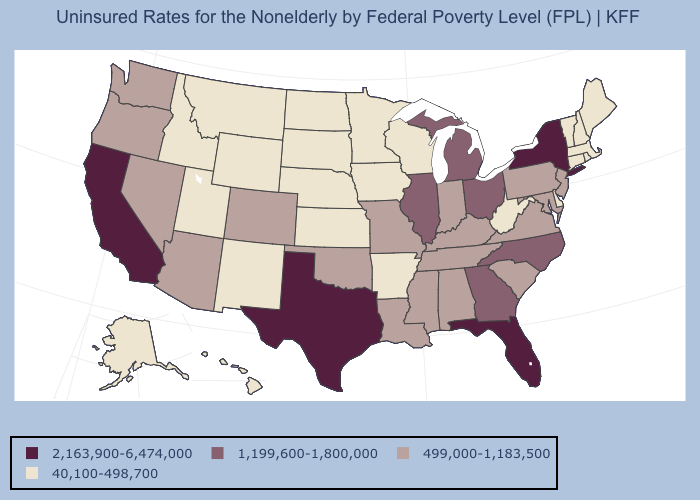Does Washington have a higher value than Illinois?
Give a very brief answer. No. What is the value of Delaware?
Answer briefly. 40,100-498,700. Among the states that border South Carolina , which have the highest value?
Short answer required. Georgia, North Carolina. Does the first symbol in the legend represent the smallest category?
Short answer required. No. Which states hav the highest value in the West?
Answer briefly. California. What is the highest value in the USA?
Concise answer only. 2,163,900-6,474,000. Name the states that have a value in the range 40,100-498,700?
Answer briefly. Alaska, Arkansas, Connecticut, Delaware, Hawaii, Idaho, Iowa, Kansas, Maine, Massachusetts, Minnesota, Montana, Nebraska, New Hampshire, New Mexico, North Dakota, Rhode Island, South Dakota, Utah, Vermont, West Virginia, Wisconsin, Wyoming. Does Florida have the highest value in the USA?
Be succinct. Yes. Among the states that border West Virginia , which have the lowest value?
Answer briefly. Kentucky, Maryland, Pennsylvania, Virginia. Which states hav the highest value in the MidWest?
Write a very short answer. Illinois, Michigan, Ohio. Name the states that have a value in the range 2,163,900-6,474,000?
Quick response, please. California, Florida, New York, Texas. Does Iowa have the lowest value in the USA?
Answer briefly. Yes. Does Ohio have the same value as Illinois?
Keep it brief. Yes. What is the value of Delaware?
Short answer required. 40,100-498,700. Name the states that have a value in the range 1,199,600-1,800,000?
Quick response, please. Georgia, Illinois, Michigan, North Carolina, Ohio. 